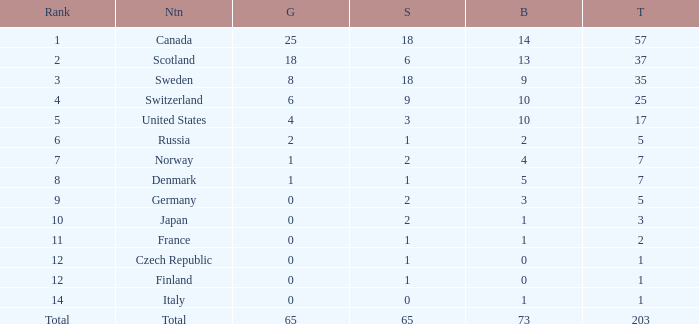What is the number of bronze medals when the total is greater than 1, more than 2 silver medals are won, and the rank is 2? 13.0. 